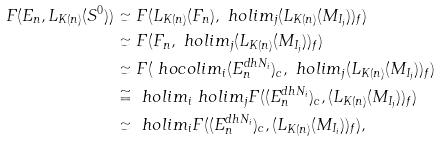Convert formula to latex. <formula><loc_0><loc_0><loc_500><loc_500>F ( E _ { n } , L _ { K ( n ) } ( S ^ { 0 } ) ) & \simeq F ( L _ { K ( n ) } ( F _ { n } ) , \ h o l i m _ { j } ( L _ { K ( n ) } ( M _ { I _ { j } } ) ) _ { f } ) \\ & \simeq F ( F _ { n } , \ h o l i m _ { j } ( L _ { K ( n ) } ( M _ { I _ { j } } ) ) _ { f } ) \\ & \simeq F ( \ h o c o l i m _ { i } ( E _ { n } ^ { d h N _ { i } } ) _ { c } , \ h o l i m _ { j } ( L _ { K ( n ) } ( M _ { I _ { j } } ) ) _ { f } ) \\ & \cong \ h o l i m _ { i } \ h o l i m _ { j } F ( ( E _ { n } ^ { d h N _ { i } } ) _ { c } , ( L _ { K ( n ) } ( M _ { I _ { j } } ) ) _ { f } ) \\ & \simeq \ h o l i m _ { i } F ( ( E _ { n } ^ { d h N _ { i } } ) _ { c } , ( L _ { K ( n ) } ( M _ { I _ { i } } ) ) _ { f } ) ,</formula> 